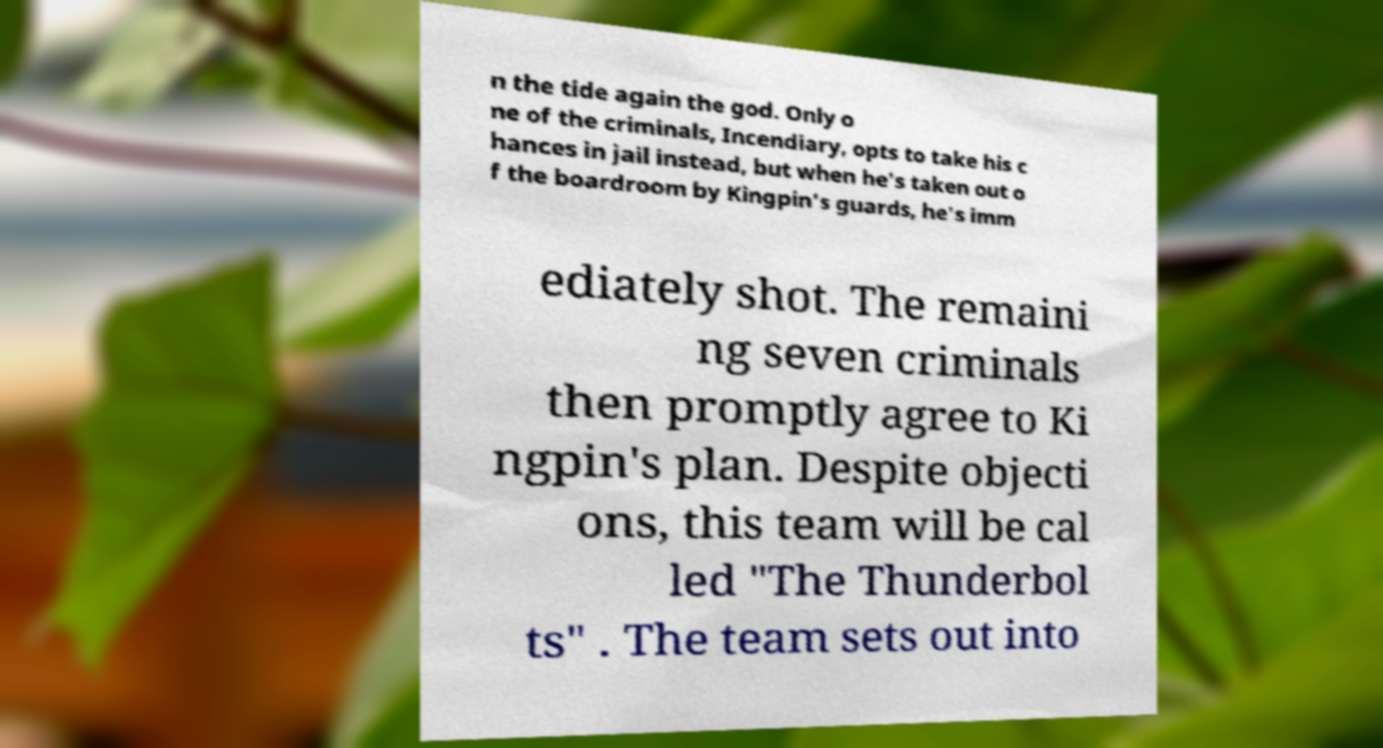Could you extract and type out the text from this image? n the tide again the god. Only o ne of the criminals, Incendiary, opts to take his c hances in jail instead, but when he's taken out o f the boardroom by Kingpin's guards, he's imm ediately shot. The remaini ng seven criminals then promptly agree to Ki ngpin's plan. Despite objecti ons, this team will be cal led "The Thunderbol ts" . The team sets out into 